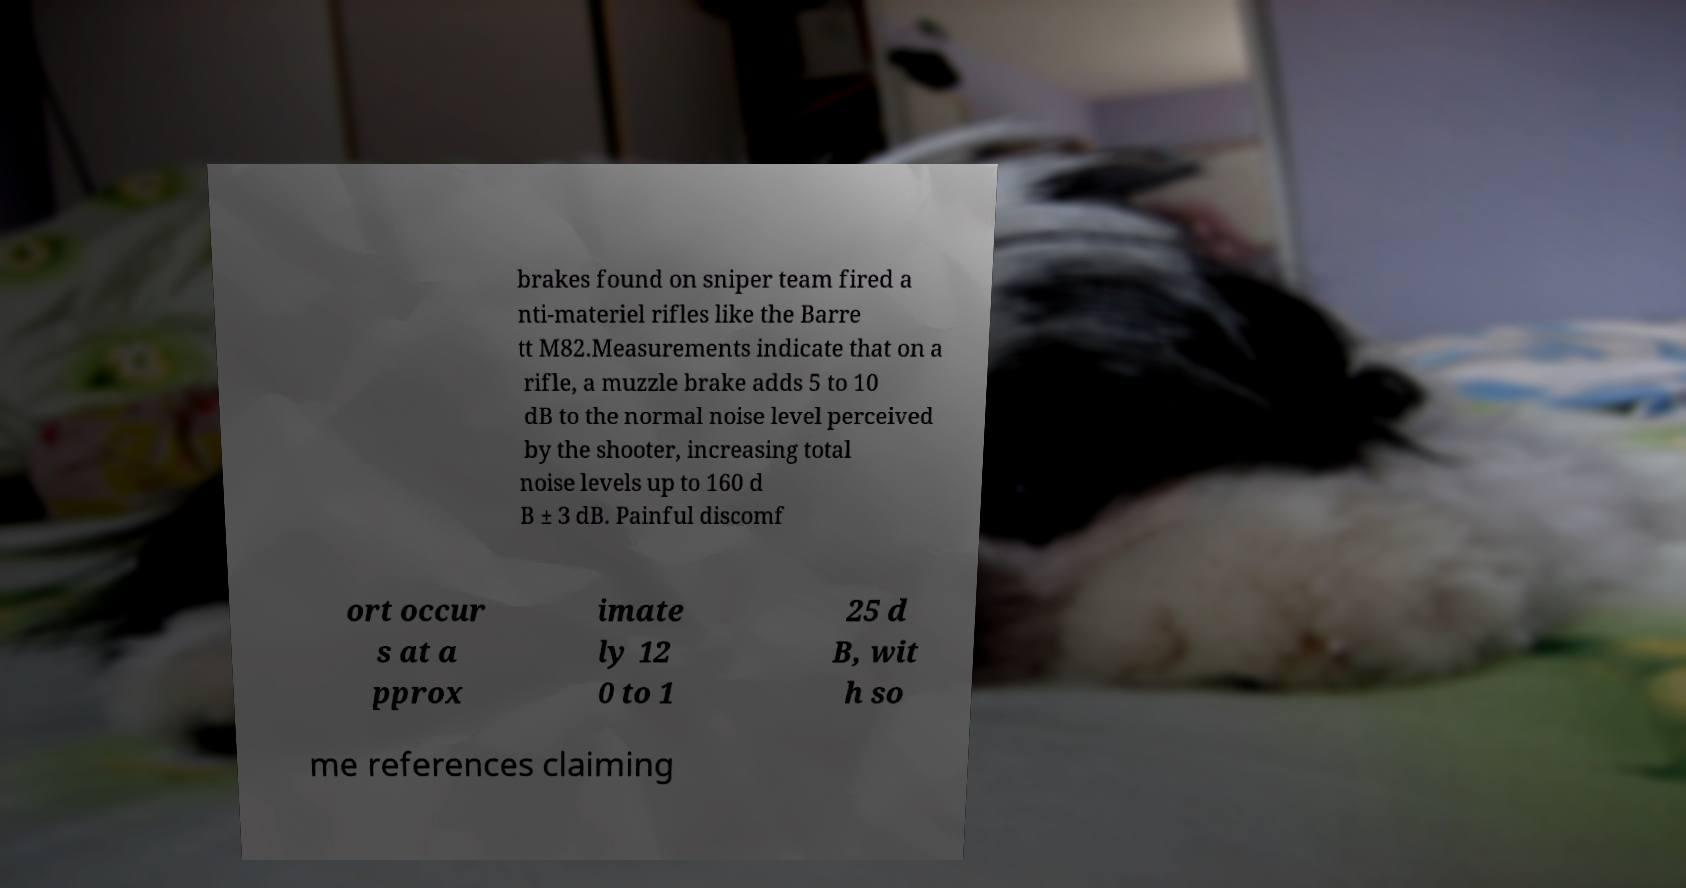Can you read and provide the text displayed in the image?This photo seems to have some interesting text. Can you extract and type it out for me? brakes found on sniper team fired a nti-materiel rifles like the Barre tt M82.Measurements indicate that on a rifle, a muzzle brake adds 5 to 10 dB to the normal noise level perceived by the shooter, increasing total noise levels up to 160 d B ± 3 dB. Painful discomf ort occur s at a pprox imate ly 12 0 to 1 25 d B, wit h so me references claiming 